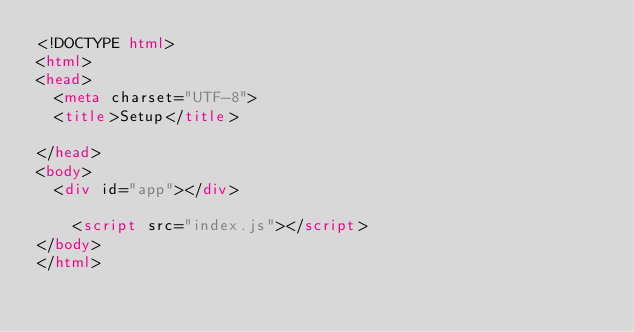<code> <loc_0><loc_0><loc_500><loc_500><_HTML_><!DOCTYPE html>
<html>
<head>
	<meta charset="UTF-8">
	<title>Setup</title>
	
</head>
<body>
	<div id="app"></div>
    
    <script src="index.js"></script>
</body>
</html></code> 